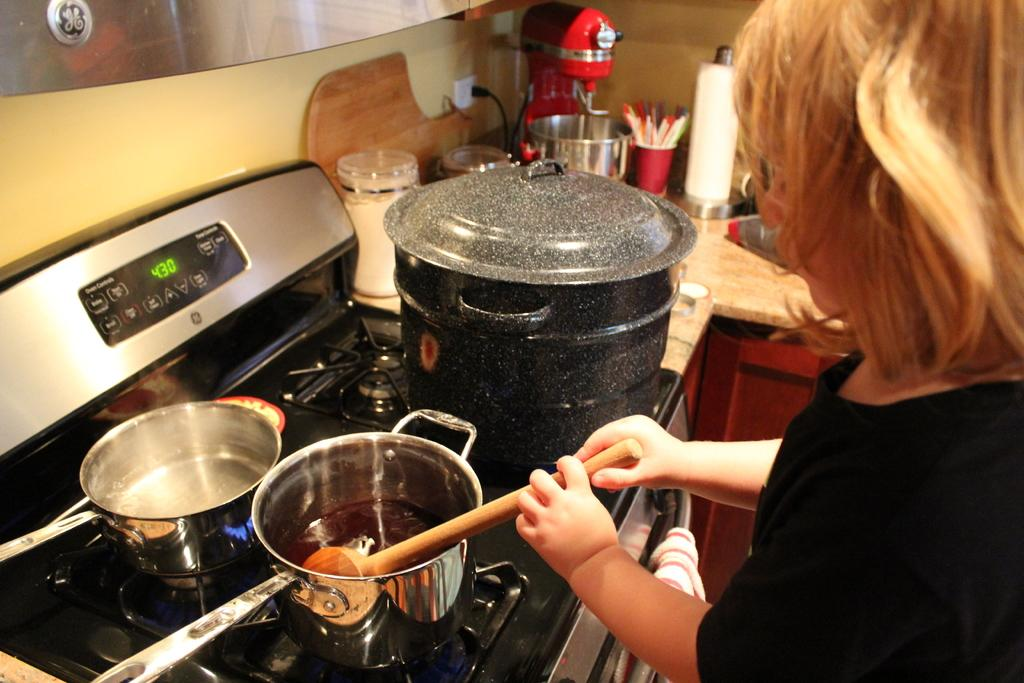<image>
Offer a succinct explanation of the picture presented. A lady is cooking using the stove, as the screen displays 4:30. 